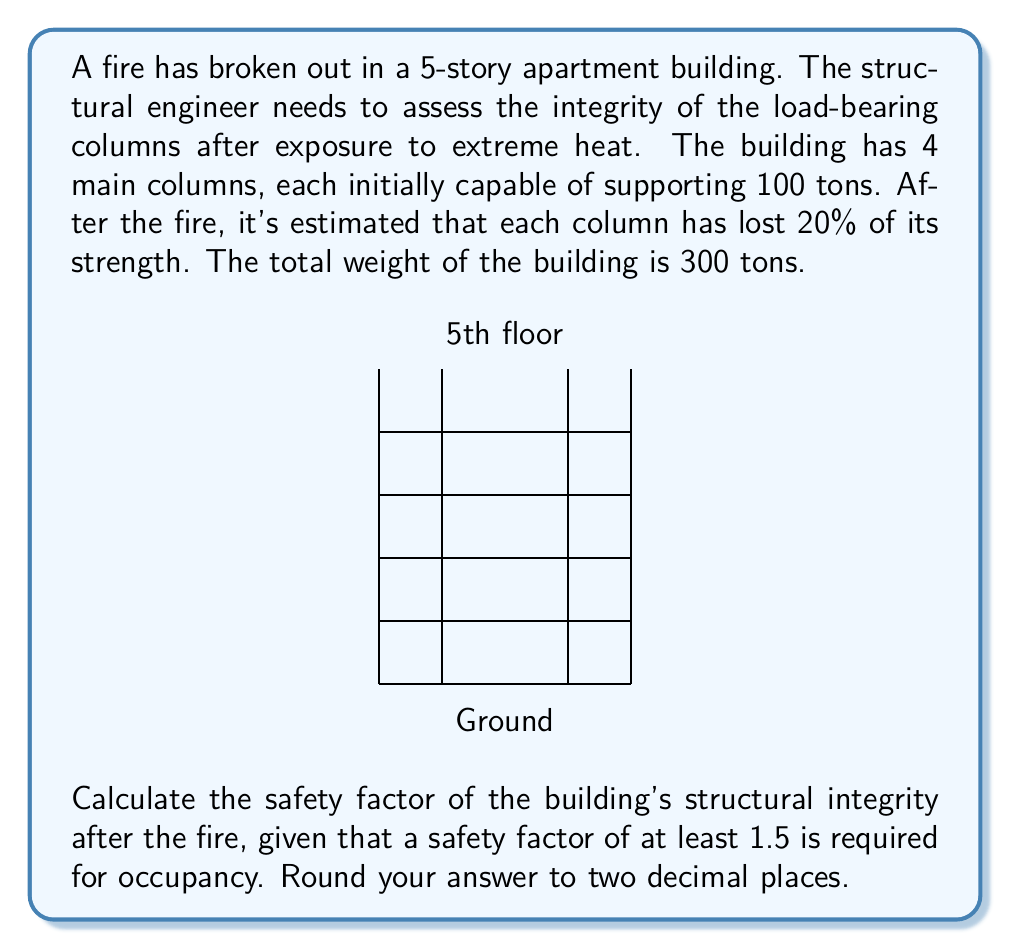Can you solve this math problem? Let's approach this step-by-step:

1) First, calculate the initial load-bearing capacity of all columns combined:
   $$ 4 \text{ columns} \times 100 \text{ tons} = 400 \text{ tons} $$

2) After the fire, each column lost 20% of its strength. Calculate the new strength:
   $$ 100 \text{ tons} \times (1 - 0.20) = 80 \text{ tons per column} $$

3) Calculate the new total load-bearing capacity:
   $$ 4 \text{ columns} \times 80 \text{ tons} = 320 \text{ tons} $$

4) The safety factor is calculated by dividing the load-bearing capacity by the actual load:
   $$ \text{Safety Factor} = \frac{\text{Load-bearing Capacity}}{\text{Actual Load}} $$

5) Plug in the values:
   $$ \text{Safety Factor} = \frac{320 \text{ tons}}{300 \text{ tons}} = 1.0666... $$

6) Rounding to two decimal places:
   $$ \text{Safety Factor} = 1.07 $$

7) Compare this to the required safety factor of 1.5:
   $$ 1.07 < 1.5 $$

Therefore, the building does not meet the required safety factor for occupancy after the fire.
Answer: 1.07 